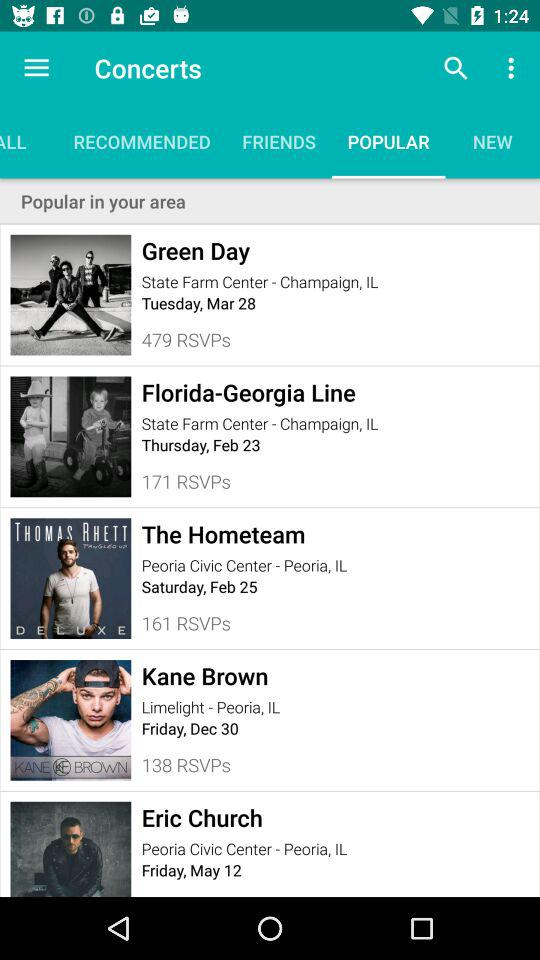What is the venue of the "Green Day" concert? The "Green Day" concert is at the "State Farm Center" in Champaign, IL. 